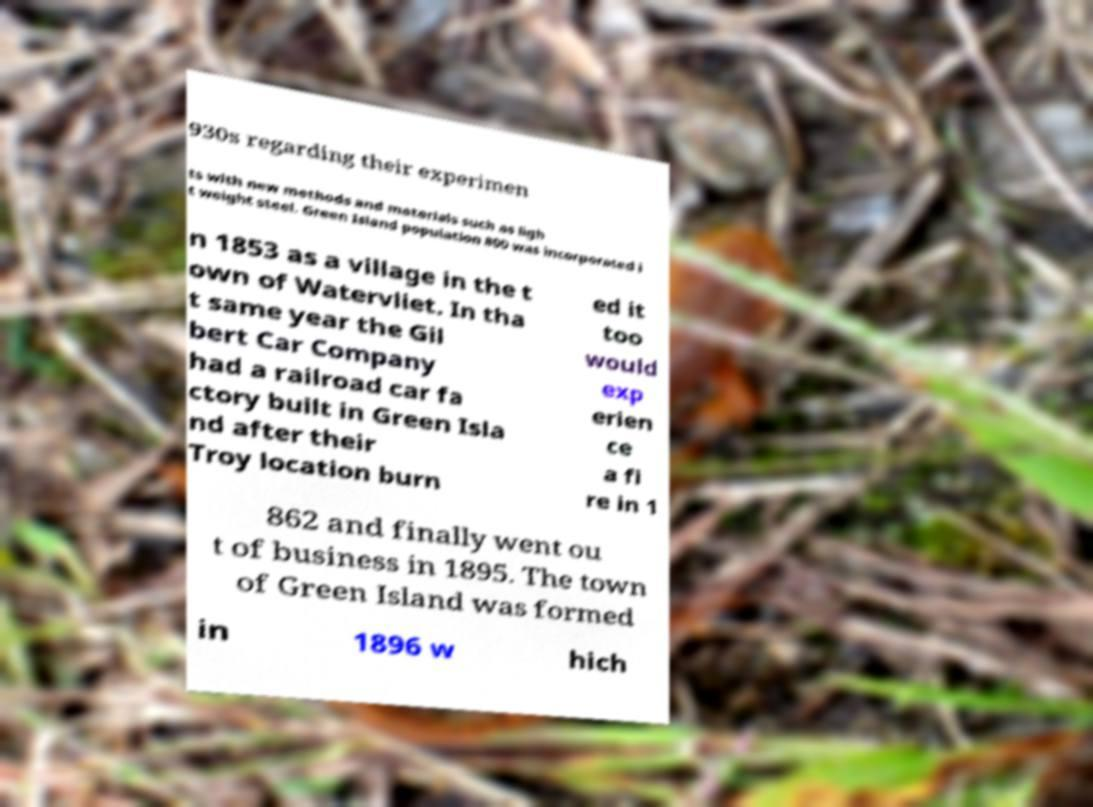Please read and relay the text visible in this image. What does it say? 930s regarding their experimen ts with new methods and materials such as ligh t weight steel. Green Island population 800 was incorporated i n 1853 as a village in the t own of Watervliet. In tha t same year the Gil bert Car Company had a railroad car fa ctory built in Green Isla nd after their Troy location burn ed it too would exp erien ce a fi re in 1 862 and finally went ou t of business in 1895. The town of Green Island was formed in 1896 w hich 